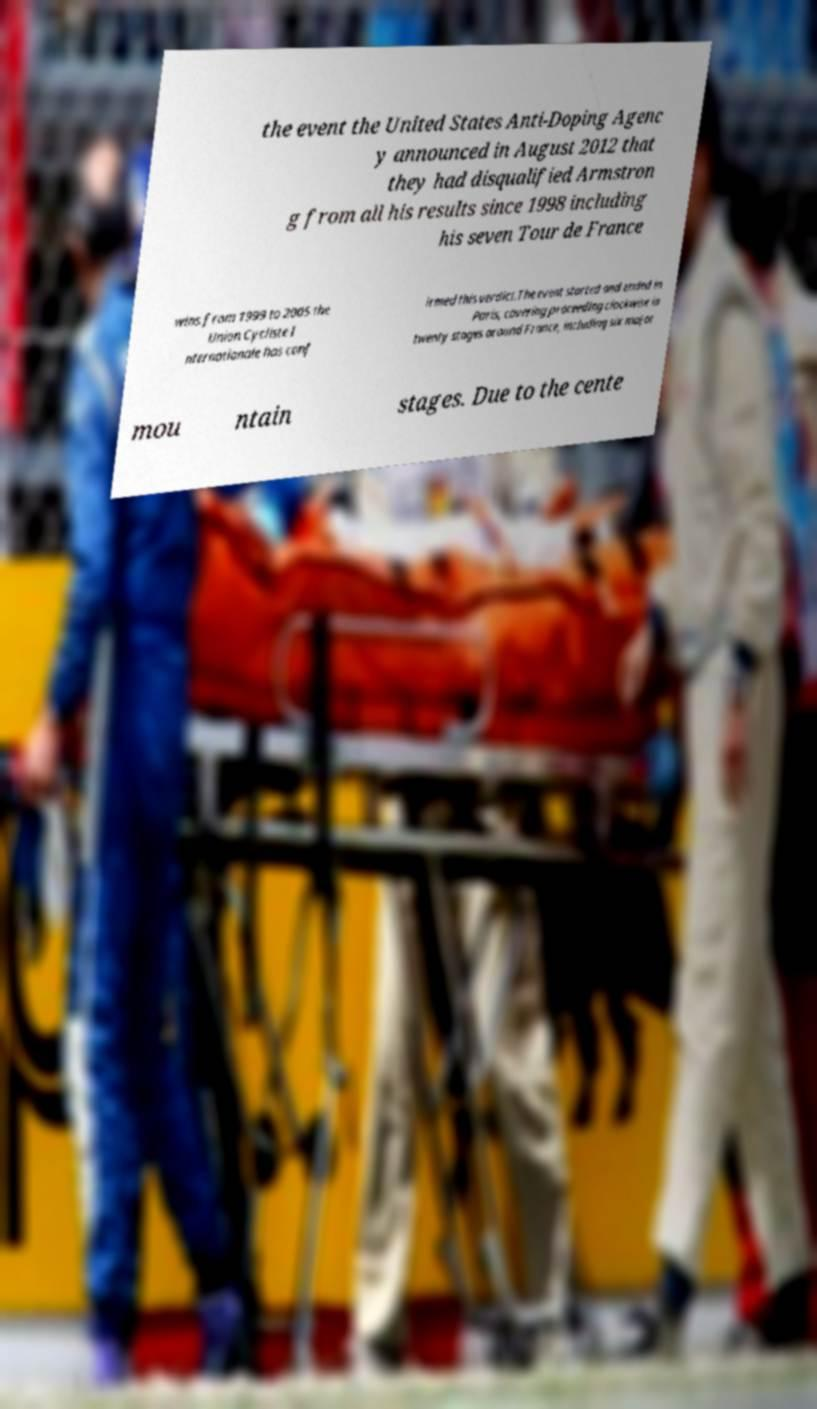There's text embedded in this image that I need extracted. Can you transcribe it verbatim? the event the United States Anti-Doping Agenc y announced in August 2012 that they had disqualified Armstron g from all his results since 1998 including his seven Tour de France wins from 1999 to 2005 the Union Cycliste I nternationale has conf irmed this verdict.The event started and ended in Paris, covering proceeding clockwise in twenty stages around France, including six major mou ntain stages. Due to the cente 